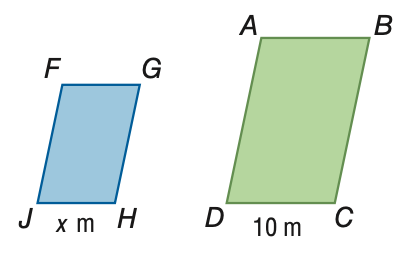Question: The area of \parallelogram A B C D is 150 square meters. The area of \parallelogram F G H J is 54 square meters. If \parallelogram A B C D \sim \parallelogram F G H J, find the scale factor of \parallelogram F G H J to \parallelogram A B C D.
Choices:
A. \frac { 9 } { 25 }
B. \frac { 3 } { 5 }
C. \frac { 5 } { 3 }
D. \frac { 25 } { 9 }
Answer with the letter. Answer: B Question: The area of \parallelogram A B C D is 150 square meters. The area of \parallelogram F G H J is 54 square meters. If \parallelogram A B C D \sim \parallelogram F G H J, find the value of x.
Choices:
A. 3.6
B. 6
C. 16.7
D. 27.8
Answer with the letter. Answer: B 